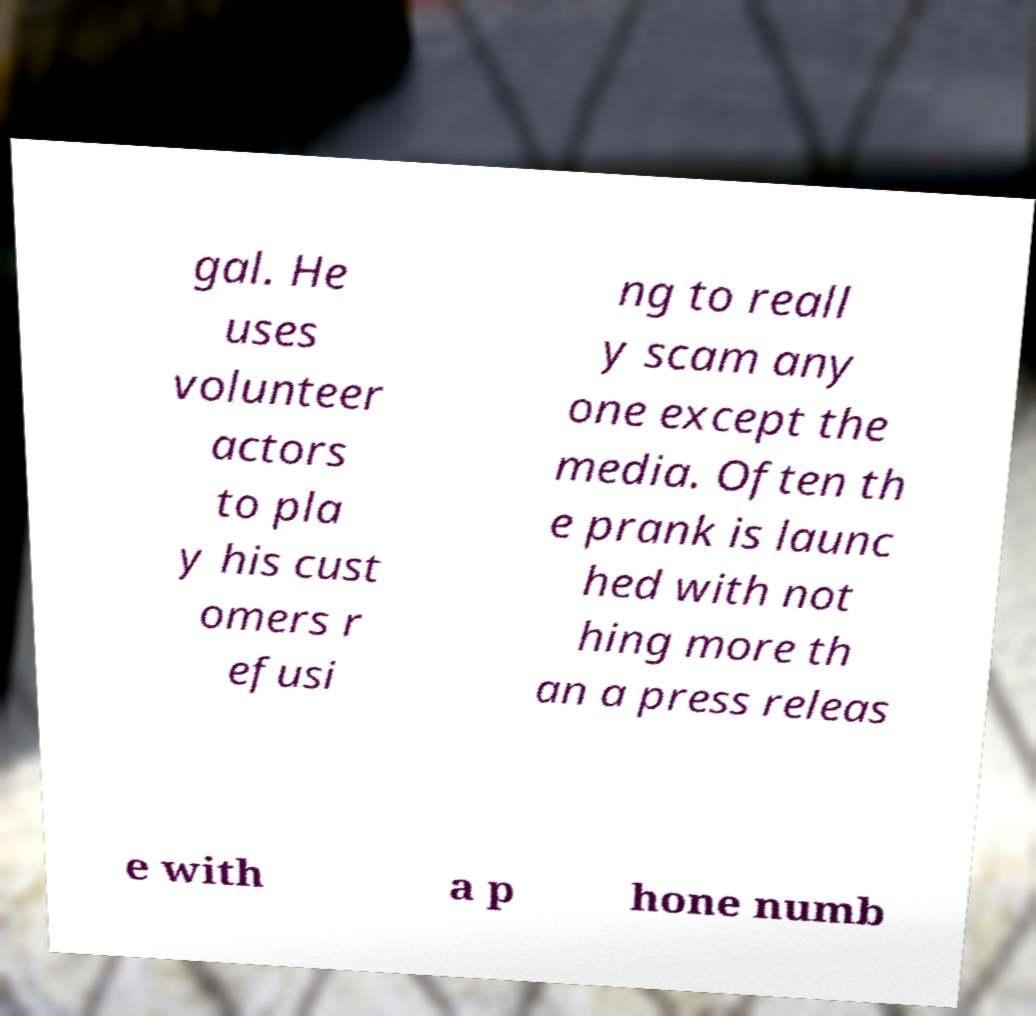Please identify and transcribe the text found in this image. gal. He uses volunteer actors to pla y his cust omers r efusi ng to reall y scam any one except the media. Often th e prank is launc hed with not hing more th an a press releas e with a p hone numb 